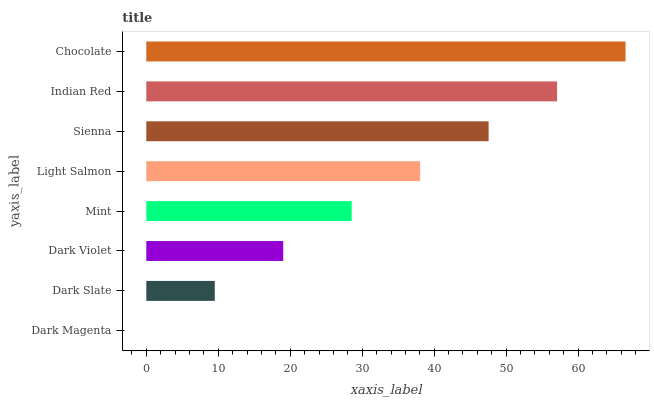Is Dark Magenta the minimum?
Answer yes or no. Yes. Is Chocolate the maximum?
Answer yes or no. Yes. Is Dark Slate the minimum?
Answer yes or no. No. Is Dark Slate the maximum?
Answer yes or no. No. Is Dark Slate greater than Dark Magenta?
Answer yes or no. Yes. Is Dark Magenta less than Dark Slate?
Answer yes or no. Yes. Is Dark Magenta greater than Dark Slate?
Answer yes or no. No. Is Dark Slate less than Dark Magenta?
Answer yes or no. No. Is Light Salmon the high median?
Answer yes or no. Yes. Is Mint the low median?
Answer yes or no. Yes. Is Dark Violet the high median?
Answer yes or no. No. Is Dark Slate the low median?
Answer yes or no. No. 